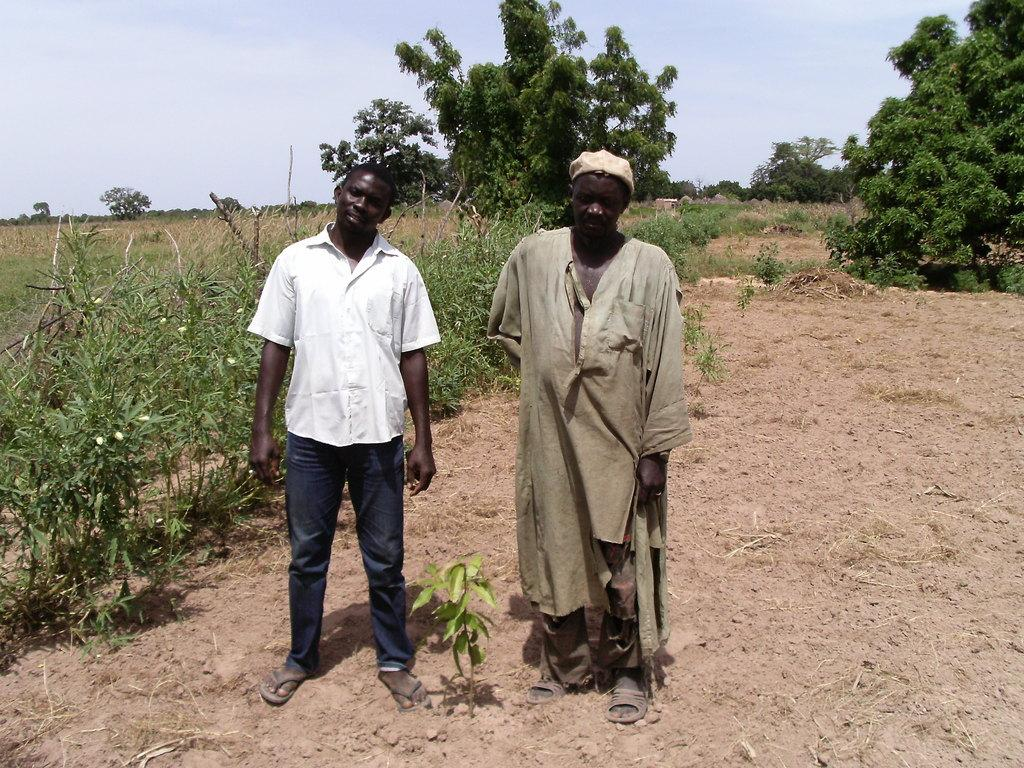How many people are in the image? There are two persons standing in the middle of the image. What are the two persons doing? The two persons are watching something. What can be seen in the background of the image? There are plants and trees visible in the background of the image. What is visible in the sky at the top of the image? There are clouds visible in the sky at the top of the image. Is there a volcano erupting in the background of the image? No, there is no volcano present in the image. How many cents are visible in the image? There are no cents visible in the image. 